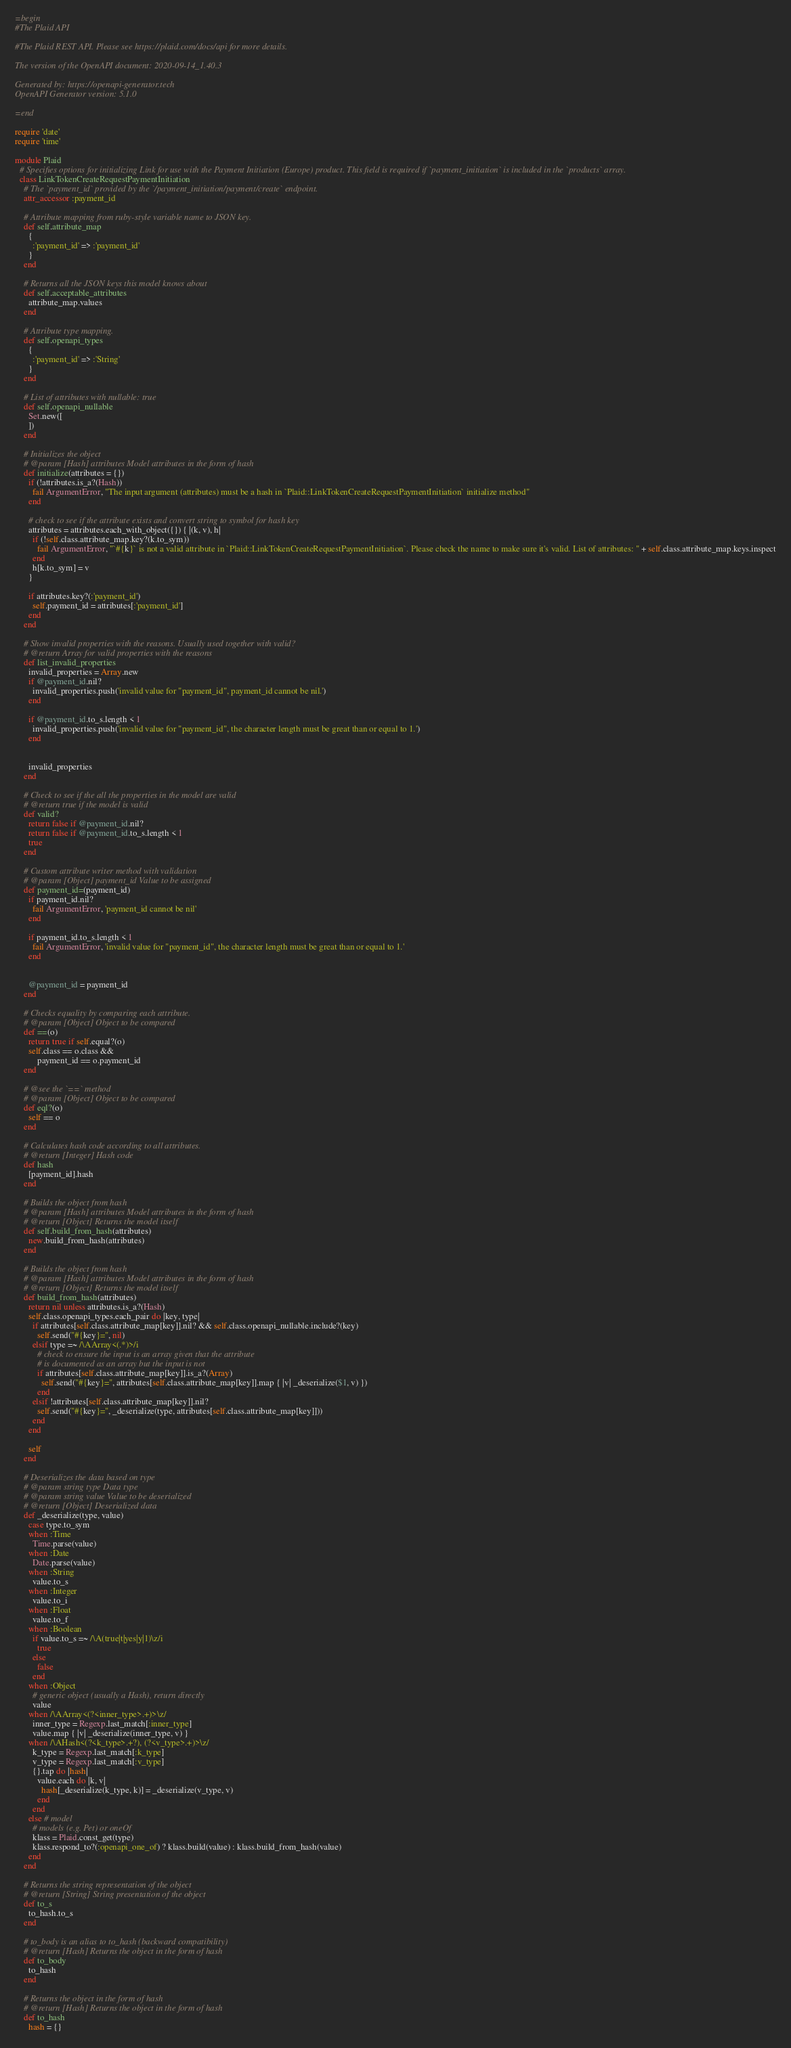<code> <loc_0><loc_0><loc_500><loc_500><_Ruby_>=begin
#The Plaid API

#The Plaid REST API. Please see https://plaid.com/docs/api for more details.

The version of the OpenAPI document: 2020-09-14_1.40.3

Generated by: https://openapi-generator.tech
OpenAPI Generator version: 5.1.0

=end

require 'date'
require 'time'

module Plaid
  # Specifies options for initializing Link for use with the Payment Initiation (Europe) product. This field is required if `payment_initiation` is included in the `products` array.
  class LinkTokenCreateRequestPaymentInitiation
    # The `payment_id` provided by the `/payment_initiation/payment/create` endpoint.
    attr_accessor :payment_id

    # Attribute mapping from ruby-style variable name to JSON key.
    def self.attribute_map
      {
        :'payment_id' => :'payment_id'
      }
    end

    # Returns all the JSON keys this model knows about
    def self.acceptable_attributes
      attribute_map.values
    end

    # Attribute type mapping.
    def self.openapi_types
      {
        :'payment_id' => :'String'
      }
    end

    # List of attributes with nullable: true
    def self.openapi_nullable
      Set.new([
      ])
    end

    # Initializes the object
    # @param [Hash] attributes Model attributes in the form of hash
    def initialize(attributes = {})
      if (!attributes.is_a?(Hash))
        fail ArgumentError, "The input argument (attributes) must be a hash in `Plaid::LinkTokenCreateRequestPaymentInitiation` initialize method"
      end

      # check to see if the attribute exists and convert string to symbol for hash key
      attributes = attributes.each_with_object({}) { |(k, v), h|
        if (!self.class.attribute_map.key?(k.to_sym))
          fail ArgumentError, "`#{k}` is not a valid attribute in `Plaid::LinkTokenCreateRequestPaymentInitiation`. Please check the name to make sure it's valid. List of attributes: " + self.class.attribute_map.keys.inspect
        end
        h[k.to_sym] = v
      }

      if attributes.key?(:'payment_id')
        self.payment_id = attributes[:'payment_id']
      end
    end

    # Show invalid properties with the reasons. Usually used together with valid?
    # @return Array for valid properties with the reasons
    def list_invalid_properties
      invalid_properties = Array.new
      if @payment_id.nil?
        invalid_properties.push('invalid value for "payment_id", payment_id cannot be nil.')
      end

      if @payment_id.to_s.length < 1
        invalid_properties.push('invalid value for "payment_id", the character length must be great than or equal to 1.')
      end


      invalid_properties
    end

    # Check to see if the all the properties in the model are valid
    # @return true if the model is valid
    def valid?
      return false if @payment_id.nil?
      return false if @payment_id.to_s.length < 1
      true
    end

    # Custom attribute writer method with validation
    # @param [Object] payment_id Value to be assigned
    def payment_id=(payment_id)
      if payment_id.nil?
        fail ArgumentError, 'payment_id cannot be nil'
      end

      if payment_id.to_s.length < 1
        fail ArgumentError, 'invalid value for "payment_id", the character length must be great than or equal to 1.'
      end


      @payment_id = payment_id
    end

    # Checks equality by comparing each attribute.
    # @param [Object] Object to be compared
    def ==(o)
      return true if self.equal?(o)
      self.class == o.class &&
          payment_id == o.payment_id
    end

    # @see the `==` method
    # @param [Object] Object to be compared
    def eql?(o)
      self == o
    end

    # Calculates hash code according to all attributes.
    # @return [Integer] Hash code
    def hash
      [payment_id].hash
    end

    # Builds the object from hash
    # @param [Hash] attributes Model attributes in the form of hash
    # @return [Object] Returns the model itself
    def self.build_from_hash(attributes)
      new.build_from_hash(attributes)
    end

    # Builds the object from hash
    # @param [Hash] attributes Model attributes in the form of hash
    # @return [Object] Returns the model itself
    def build_from_hash(attributes)
      return nil unless attributes.is_a?(Hash)
      self.class.openapi_types.each_pair do |key, type|
        if attributes[self.class.attribute_map[key]].nil? && self.class.openapi_nullable.include?(key)
          self.send("#{key}=", nil)
        elsif type =~ /\AArray<(.*)>/i
          # check to ensure the input is an array given that the attribute
          # is documented as an array but the input is not
          if attributes[self.class.attribute_map[key]].is_a?(Array)
            self.send("#{key}=", attributes[self.class.attribute_map[key]].map { |v| _deserialize($1, v) })
          end
        elsif !attributes[self.class.attribute_map[key]].nil?
          self.send("#{key}=", _deserialize(type, attributes[self.class.attribute_map[key]]))
        end
      end

      self
    end

    # Deserializes the data based on type
    # @param string type Data type
    # @param string value Value to be deserialized
    # @return [Object] Deserialized data
    def _deserialize(type, value)
      case type.to_sym
      when :Time
        Time.parse(value)
      when :Date
        Date.parse(value)
      when :String
        value.to_s
      when :Integer
        value.to_i
      when :Float
        value.to_f
      when :Boolean
        if value.to_s =~ /\A(true|t|yes|y|1)\z/i
          true
        else
          false
        end
      when :Object
        # generic object (usually a Hash), return directly
        value
      when /\AArray<(?<inner_type>.+)>\z/
        inner_type = Regexp.last_match[:inner_type]
        value.map { |v| _deserialize(inner_type, v) }
      when /\AHash<(?<k_type>.+?), (?<v_type>.+)>\z/
        k_type = Regexp.last_match[:k_type]
        v_type = Regexp.last_match[:v_type]
        {}.tap do |hash|
          value.each do |k, v|
            hash[_deserialize(k_type, k)] = _deserialize(v_type, v)
          end
        end
      else # model
        # models (e.g. Pet) or oneOf
        klass = Plaid.const_get(type)
        klass.respond_to?(:openapi_one_of) ? klass.build(value) : klass.build_from_hash(value)
      end
    end

    # Returns the string representation of the object
    # @return [String] String presentation of the object
    def to_s
      to_hash.to_s
    end

    # to_body is an alias to to_hash (backward compatibility)
    # @return [Hash] Returns the object in the form of hash
    def to_body
      to_hash
    end

    # Returns the object in the form of hash
    # @return [Hash] Returns the object in the form of hash
    def to_hash
      hash = {}</code> 